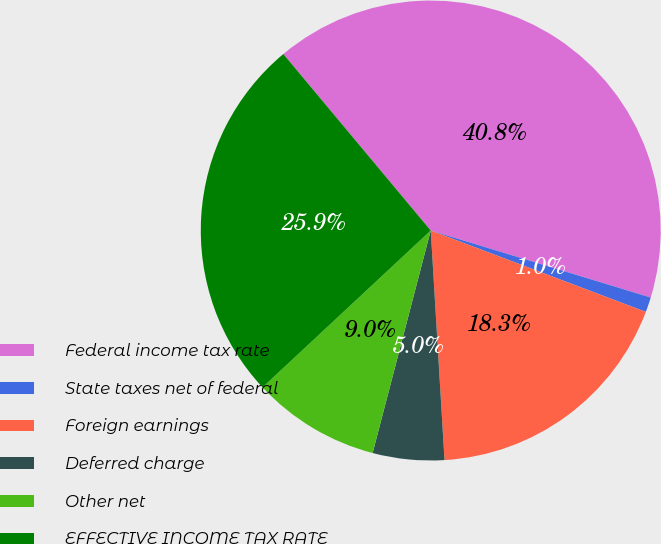Convert chart to OTSL. <chart><loc_0><loc_0><loc_500><loc_500><pie_chart><fcel>Federal income tax rate<fcel>State taxes net of federal<fcel>Foreign earnings<fcel>Deferred charge<fcel>Other net<fcel>EFFECTIVE INCOME TAX RATE<nl><fcel>40.78%<fcel>1.05%<fcel>18.29%<fcel>5.02%<fcel>8.99%<fcel>25.87%<nl></chart> 